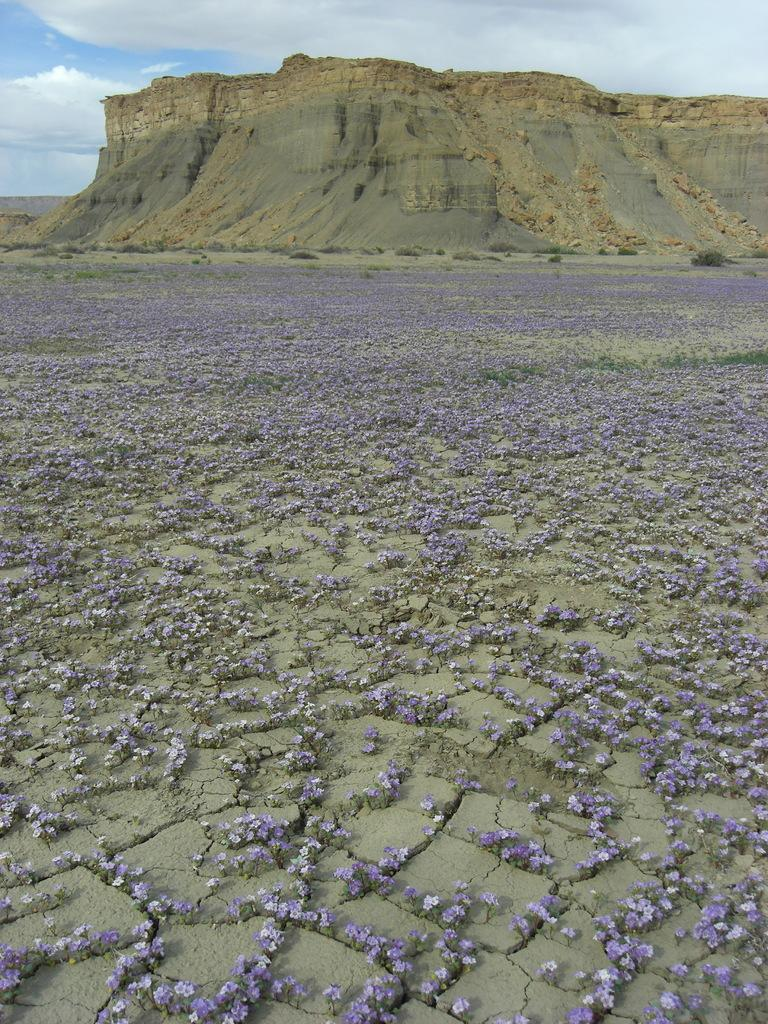What type of vegetation can be seen on the ground in the image? There are flowers on the ground in the image. What type of landscape feature is visible in the image? There are hills visible in the image. What part of the natural environment is visible in the image? The sky is visible in the image. What can be seen in the sky in the image? Clouds are present in the sky. What type of insect can be seen crawling on the actor's face in the image? There is no actor or insect present in the image; it features flowers, hills, and clouds. 